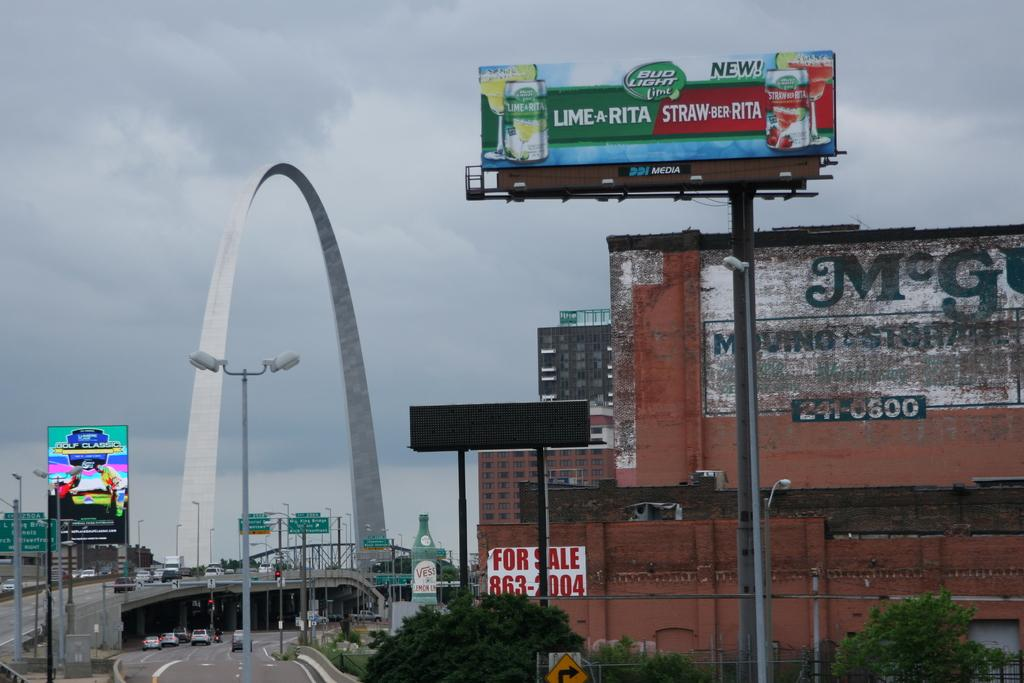<image>
Relay a brief, clear account of the picture shown. an advertisement with a strawberita logo on it 